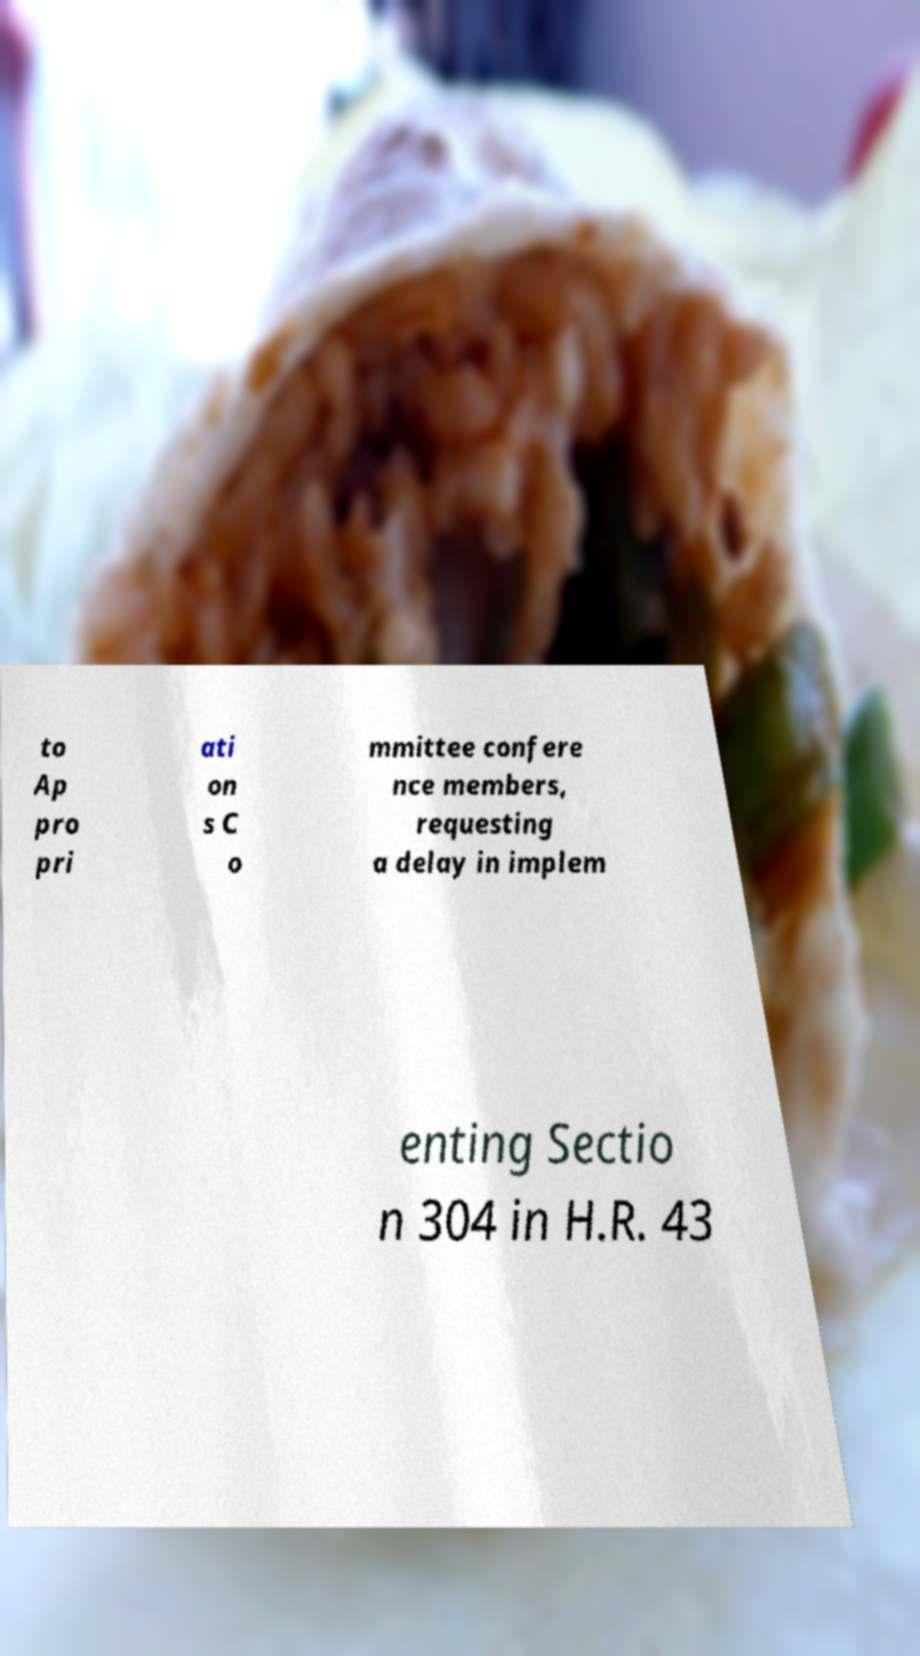Can you read and provide the text displayed in the image?This photo seems to have some interesting text. Can you extract and type it out for me? to Ap pro pri ati on s C o mmittee confere nce members, requesting a delay in implem enting Sectio n 304 in H.R. 43 